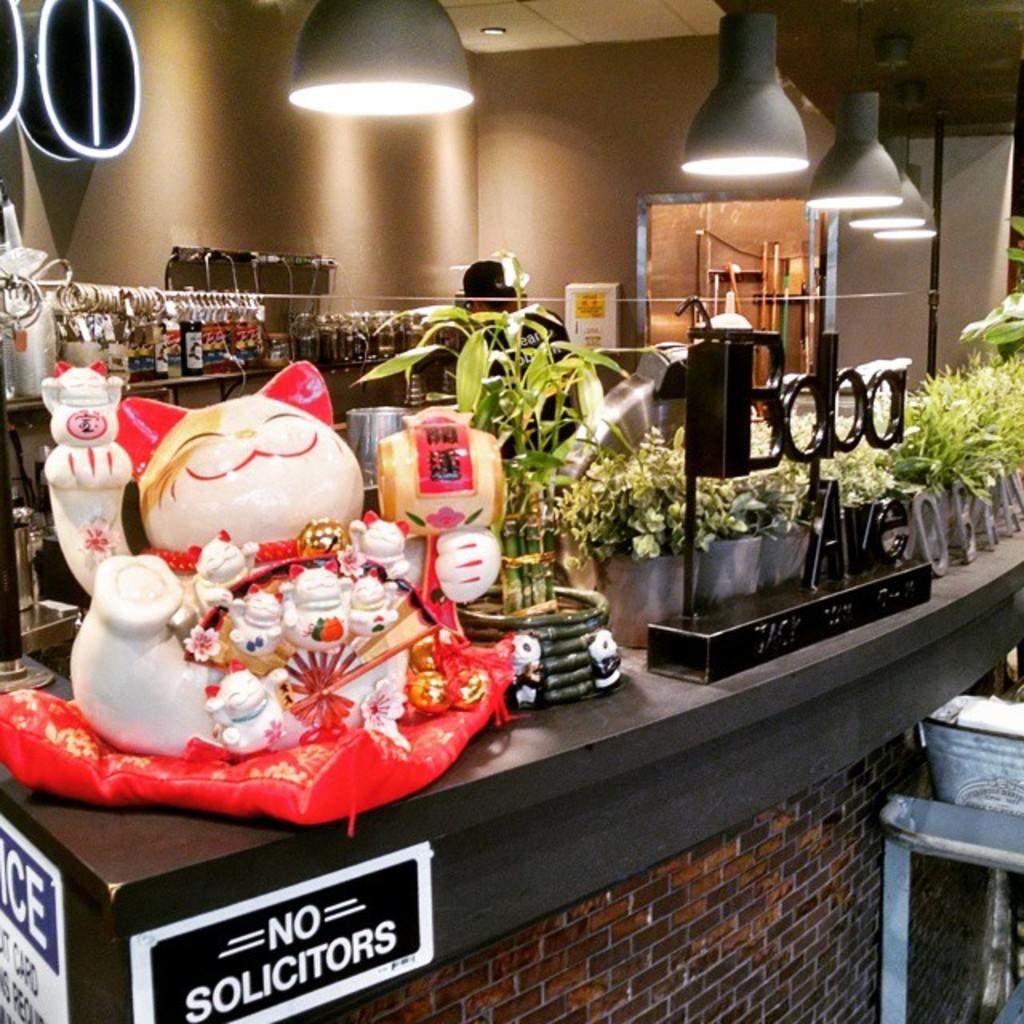<image>
Give a short and clear explanation of the subsequent image. A counter with a waving cat statue, many plants, and a sign stating No Solicitors. 